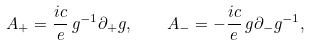<formula> <loc_0><loc_0><loc_500><loc_500>A _ { + } = \frac { i c } { e } \, g ^ { - 1 } \partial _ { + } g , \quad A _ { - } = - \frac { i c } { e } \, g \partial _ { - } g ^ { - 1 } ,</formula> 